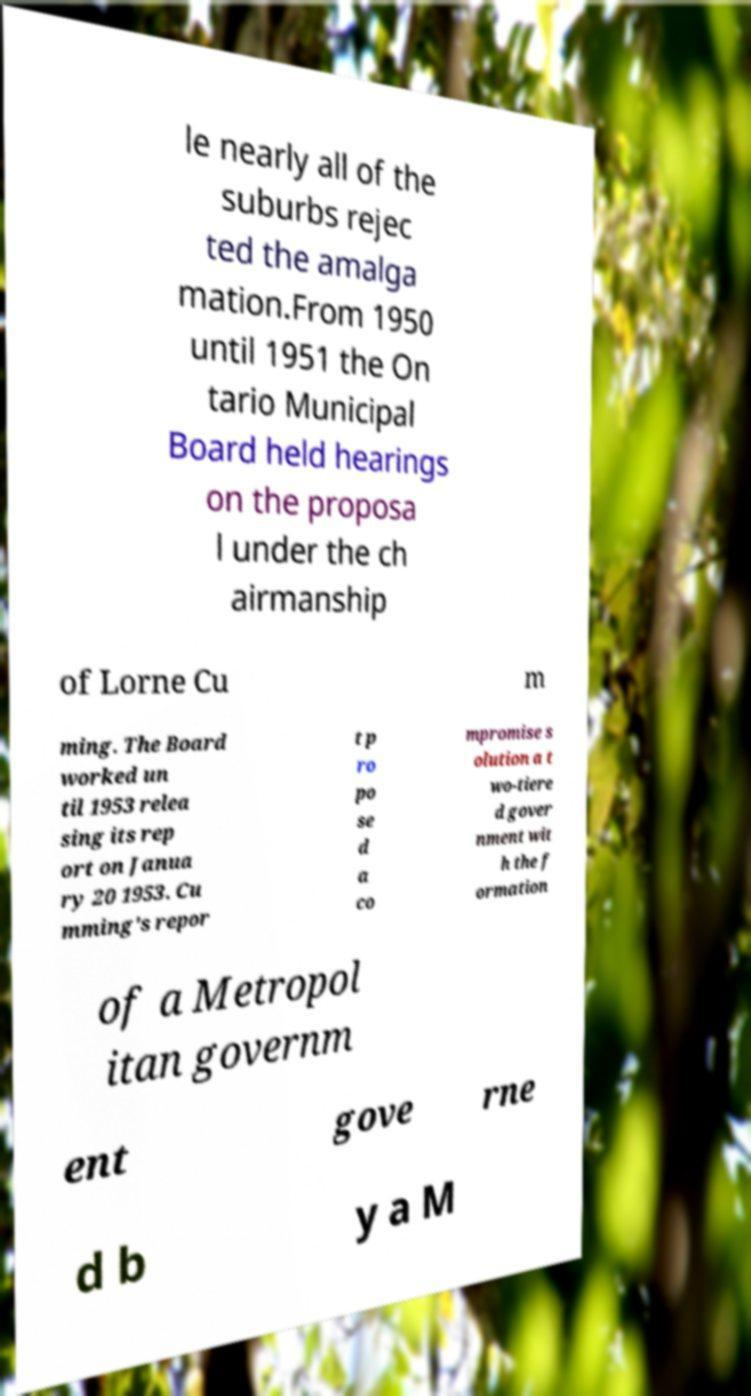There's text embedded in this image that I need extracted. Can you transcribe it verbatim? le nearly all of the suburbs rejec ted the amalga mation.From 1950 until 1951 the On tario Municipal Board held hearings on the proposa l under the ch airmanship of Lorne Cu m ming. The Board worked un til 1953 relea sing its rep ort on Janua ry 20 1953. Cu mming's repor t p ro po se d a co mpromise s olution a t wo-tiere d gover nment wit h the f ormation of a Metropol itan governm ent gove rne d b y a M 